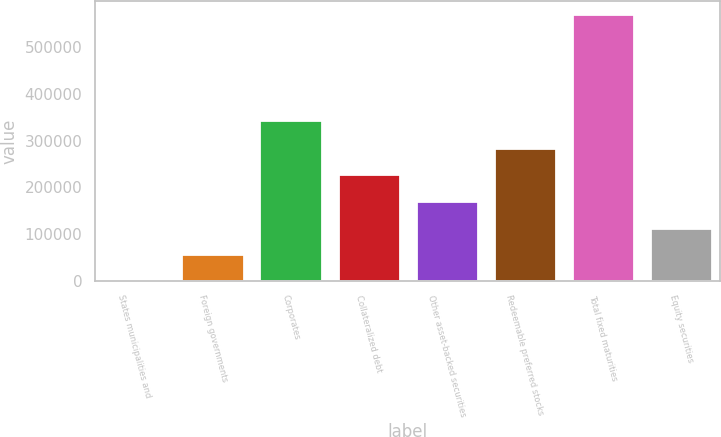Convert chart to OTSL. <chart><loc_0><loc_0><loc_500><loc_500><bar_chart><fcel>States municipalities and<fcel>Foreign governments<fcel>Corporates<fcel>Collateralized debt<fcel>Other asset-backed securities<fcel>Redeemable preferred stocks<fcel>Total fixed maturities<fcel>Equity securities<nl><fcel>2.44<fcel>57048.7<fcel>343987<fcel>228187<fcel>171141<fcel>285234<fcel>570465<fcel>114095<nl></chart> 